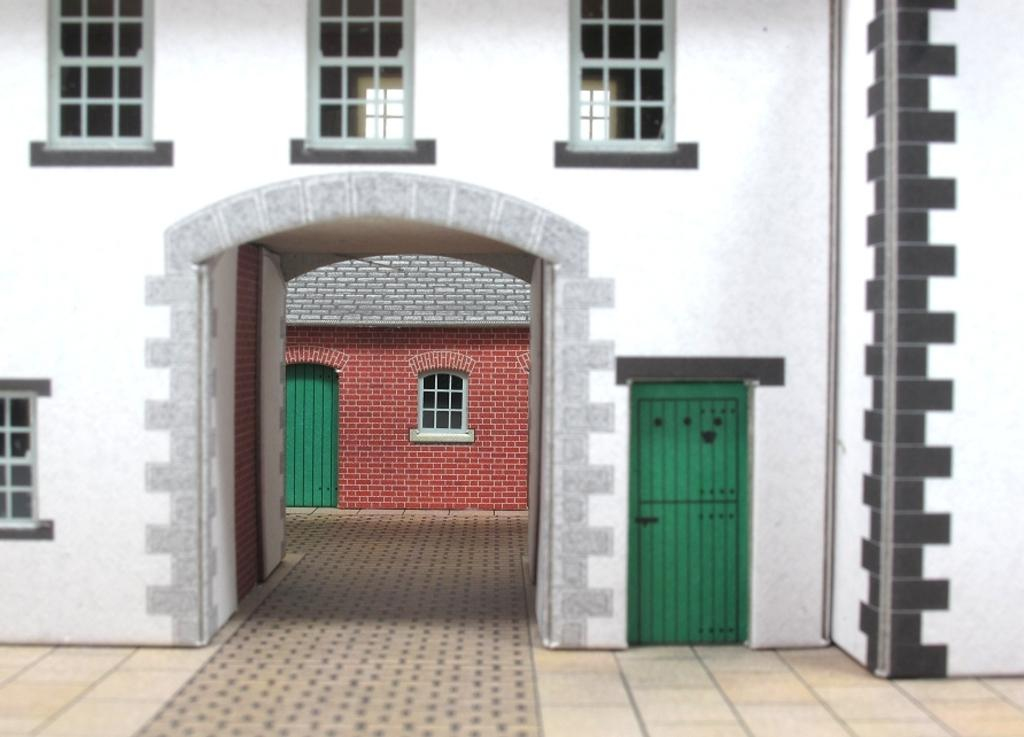What type of structure is in the image? There is a building in the image. What features can be observed on the building? The building has windows and a green color door. Can you describe the background of the image? There is another building in the background, which is in red color. How many women are playing the drum in the image? There are no women or drums present in the image. 